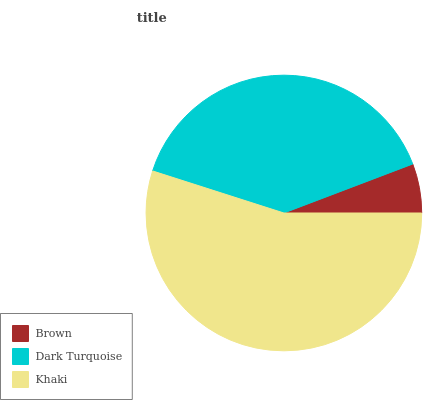Is Brown the minimum?
Answer yes or no. Yes. Is Khaki the maximum?
Answer yes or no. Yes. Is Dark Turquoise the minimum?
Answer yes or no. No. Is Dark Turquoise the maximum?
Answer yes or no. No. Is Dark Turquoise greater than Brown?
Answer yes or no. Yes. Is Brown less than Dark Turquoise?
Answer yes or no. Yes. Is Brown greater than Dark Turquoise?
Answer yes or no. No. Is Dark Turquoise less than Brown?
Answer yes or no. No. Is Dark Turquoise the high median?
Answer yes or no. Yes. Is Dark Turquoise the low median?
Answer yes or no. Yes. Is Khaki the high median?
Answer yes or no. No. Is Brown the low median?
Answer yes or no. No. 